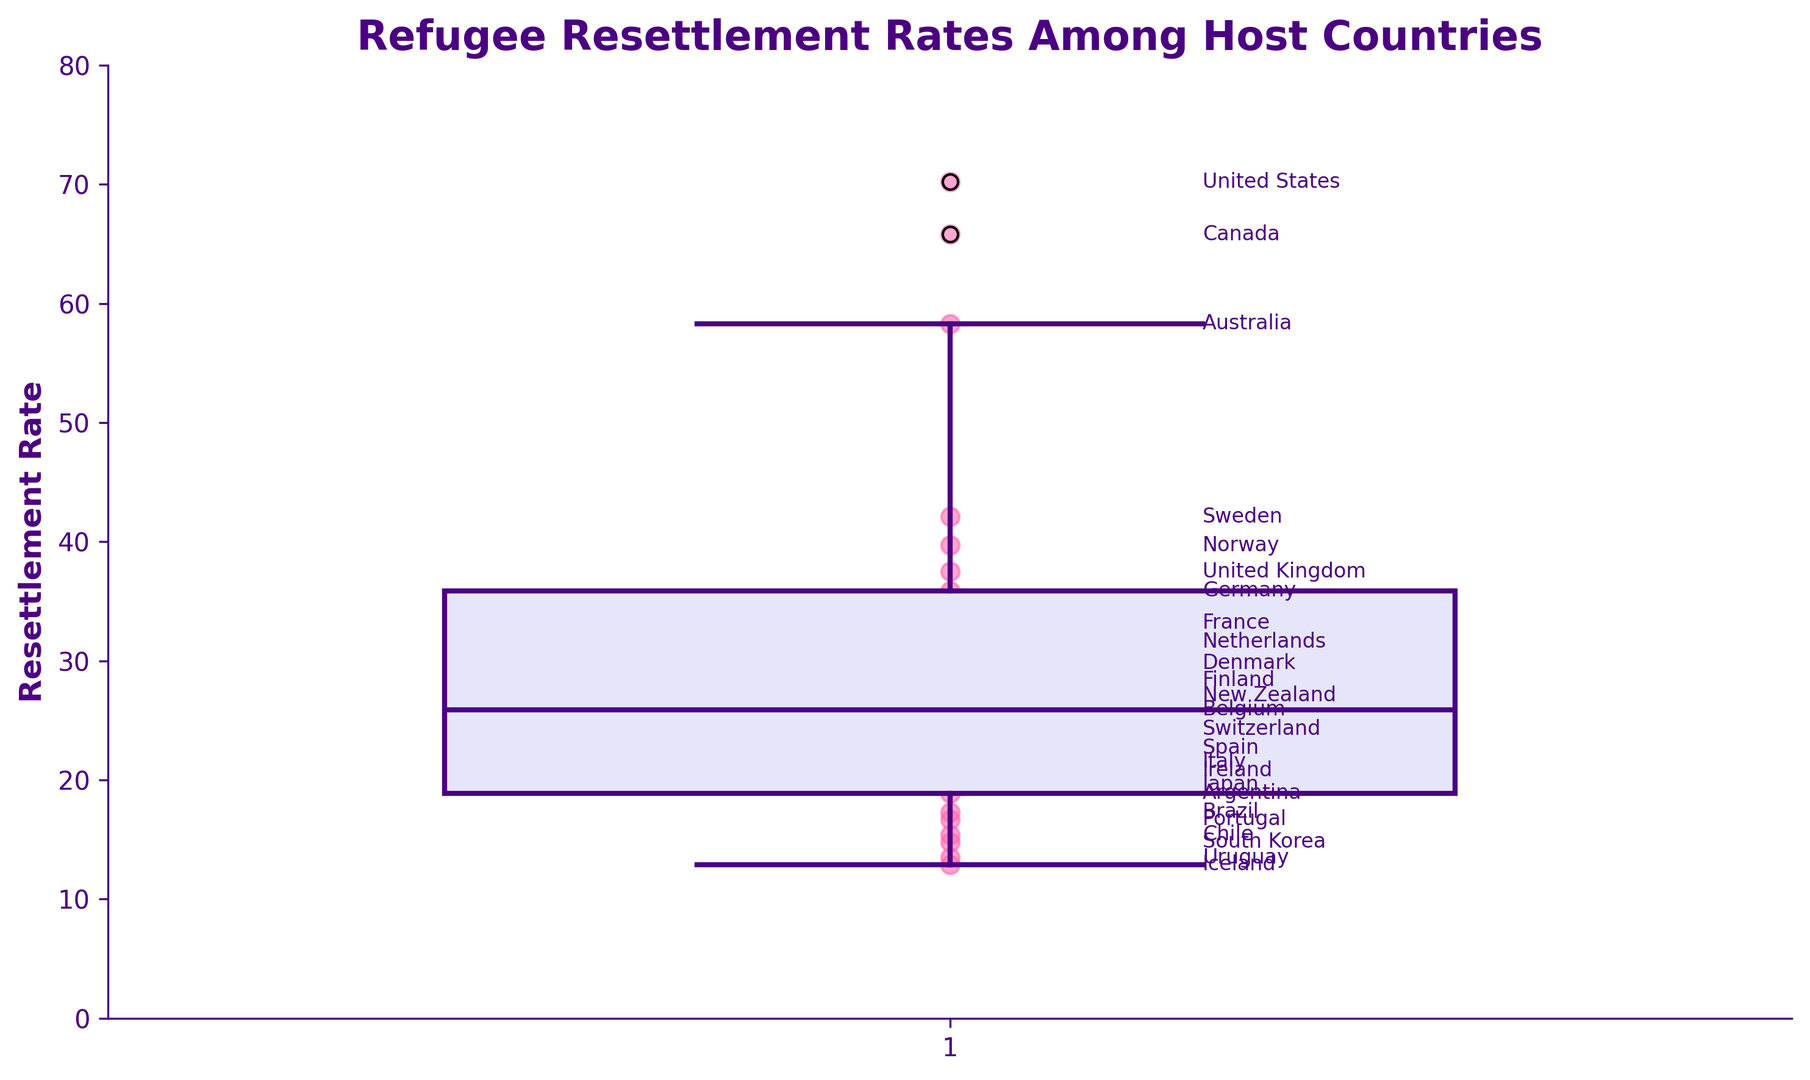What's the median resettlement rate among the host countries? The median is the middle value in the box plot, which is represented by the line inside the box. From the plot, identify the position of this line.
Answer: 25.9 Which country has the highest resettlement rate and what is that rate? The highest resettlement rate is indicated by the highest data point on the y-axis. Identify the country labeled next to this point.
Answer: United States, 70.2 What is the color used for the boxes in the box plot? The boxes in the box plot are filled with a specific color. Identify this color by observing the plot.
Answer: Light purple (lavender) Which countries have resettlement rates lower than 20? To find this, look for data points or labels below the 20 mark on the y-axis. Identify the countries associated with these points.
Answer: Japan, Argentina, Brazil, Portugal, Chile, South Korea, Uruguay, Iceland What is the difference between the highest and the lowest resettlement rates? Subtract the lowest resettlement rate from the highest. Find these values on the y-axis to perform the calculation.
Answer: 70.2 - 12.9 = 57.3 How does the resettlement rate of Sweden compare to that of Germany? Locate the points and labels for Sweden and Germany, then note their positions on the y-axis to compare.
Answer: Sweden's rate (42.1) is higher than Germany's rate (35.9) What color are the whiskers in the box plot? Observe the color of the lines extending from the boxes to the minimum and maximum data points. Identify this color.
Answer: Dark indigo What is the resettlement rate of the country closest to the median value? The median value is identified inside the box, which is 25.9. Find the country label closest to this rate.
Answer: Belgium, 25.9 Which country has a resettlement rate closest to 30? On the y-axis, find the point closest to the value of 30 and note the label of the country corresponding to this point.
Answer: Denmark, 29.8 Are there more countries with resettlement rates higher or lower than the median value? Count the number of data points above and below the median line inside the box to compare.
Answer: Lower 